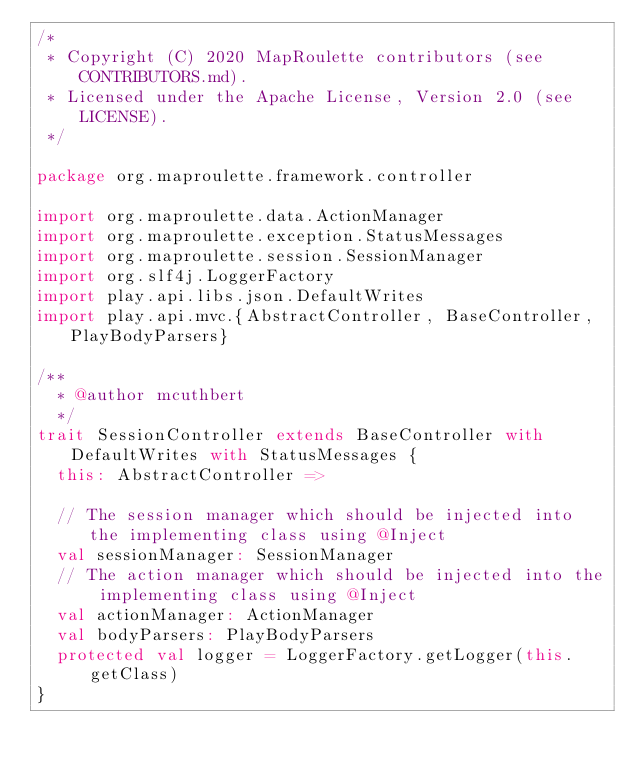Convert code to text. <code><loc_0><loc_0><loc_500><loc_500><_Scala_>/*
 * Copyright (C) 2020 MapRoulette contributors (see CONTRIBUTORS.md).
 * Licensed under the Apache License, Version 2.0 (see LICENSE).
 */

package org.maproulette.framework.controller

import org.maproulette.data.ActionManager
import org.maproulette.exception.StatusMessages
import org.maproulette.session.SessionManager
import org.slf4j.LoggerFactory
import play.api.libs.json.DefaultWrites
import play.api.mvc.{AbstractController, BaseController, PlayBodyParsers}

/**
  * @author mcuthbert
  */
trait SessionController extends BaseController with DefaultWrites with StatusMessages {
  this: AbstractController =>

  // The session manager which should be injected into the implementing class using @Inject
  val sessionManager: SessionManager
  // The action manager which should be injected into the implementing class using @Inject
  val actionManager: ActionManager
  val bodyParsers: PlayBodyParsers
  protected val logger = LoggerFactory.getLogger(this.getClass)
}
</code> 